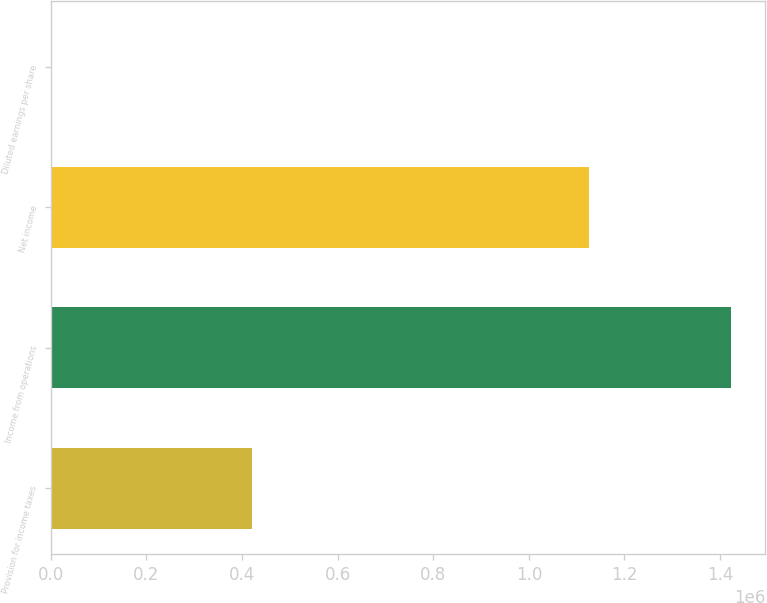Convert chart to OTSL. <chart><loc_0><loc_0><loc_500><loc_500><bar_chart><fcel>Provision for income taxes<fcel>Income from operations<fcel>Net income<fcel>Diluted earnings per share<nl><fcel>421418<fcel>1.42296e+06<fcel>1.12564e+06<fcel>0.79<nl></chart> 